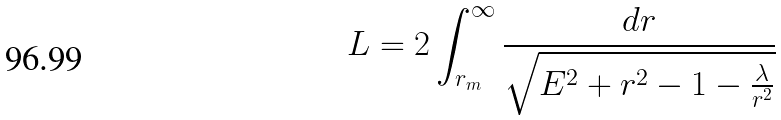Convert formula to latex. <formula><loc_0><loc_0><loc_500><loc_500>L = 2 \int _ { r _ { m } } ^ { \infty } \frac { d r } { \sqrt { E ^ { 2 } + r ^ { 2 } - 1 - \frac { \lambda } { r ^ { 2 } } } }</formula> 